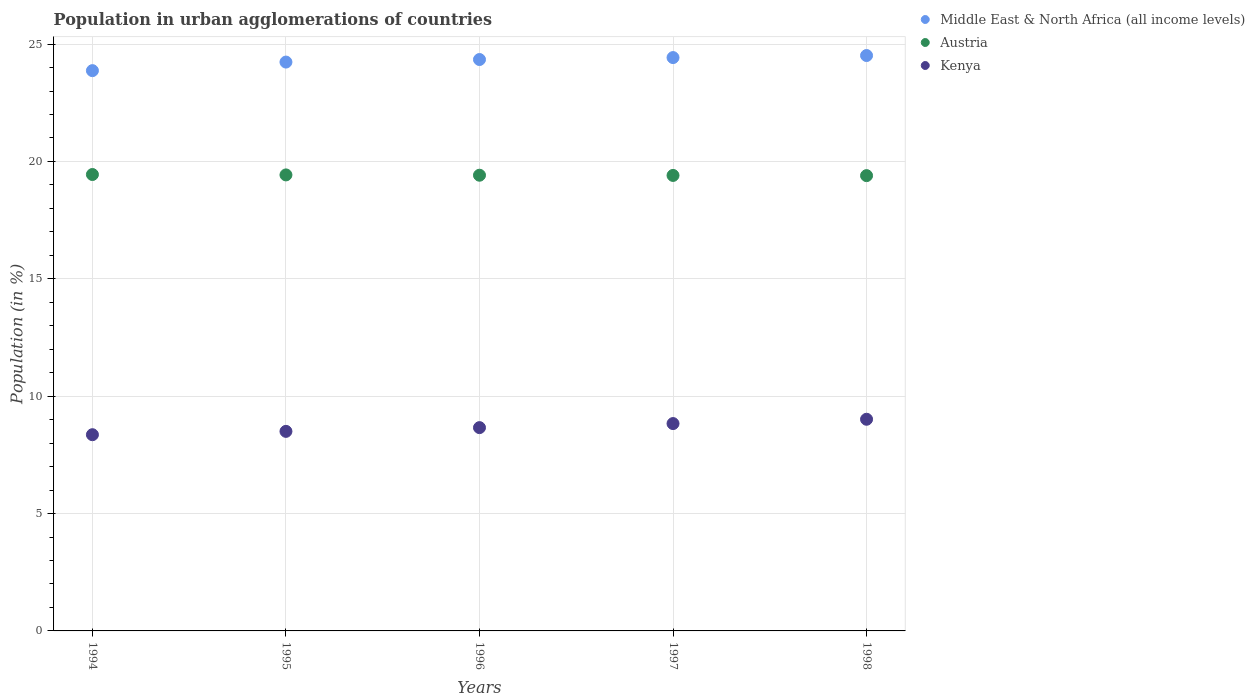Is the number of dotlines equal to the number of legend labels?
Offer a very short reply. Yes. What is the percentage of population in urban agglomerations in Austria in 1997?
Provide a short and direct response. 19.4. Across all years, what is the maximum percentage of population in urban agglomerations in Kenya?
Provide a succinct answer. 9.02. Across all years, what is the minimum percentage of population in urban agglomerations in Austria?
Your answer should be very brief. 19.4. What is the total percentage of population in urban agglomerations in Kenya in the graph?
Give a very brief answer. 43.37. What is the difference between the percentage of population in urban agglomerations in Austria in 1995 and that in 1996?
Provide a short and direct response. 0.01. What is the difference between the percentage of population in urban agglomerations in Kenya in 1997 and the percentage of population in urban agglomerations in Austria in 1996?
Offer a terse response. -10.58. What is the average percentage of population in urban agglomerations in Middle East & North Africa (all income levels) per year?
Your response must be concise. 24.28. In the year 1994, what is the difference between the percentage of population in urban agglomerations in Austria and percentage of population in urban agglomerations in Kenya?
Make the answer very short. 11.08. What is the ratio of the percentage of population in urban agglomerations in Middle East & North Africa (all income levels) in 1995 to that in 1997?
Your answer should be compact. 0.99. Is the percentage of population in urban agglomerations in Middle East & North Africa (all income levels) in 1994 less than that in 1995?
Offer a very short reply. Yes. What is the difference between the highest and the second highest percentage of population in urban agglomerations in Kenya?
Offer a terse response. 0.18. What is the difference between the highest and the lowest percentage of population in urban agglomerations in Austria?
Make the answer very short. 0.05. Is the sum of the percentage of population in urban agglomerations in Kenya in 1997 and 1998 greater than the maximum percentage of population in urban agglomerations in Middle East & North Africa (all income levels) across all years?
Give a very brief answer. No. Is it the case that in every year, the sum of the percentage of population in urban agglomerations in Middle East & North Africa (all income levels) and percentage of population in urban agglomerations in Austria  is greater than the percentage of population in urban agglomerations in Kenya?
Provide a short and direct response. Yes. How many dotlines are there?
Make the answer very short. 3. What is the difference between two consecutive major ticks on the Y-axis?
Make the answer very short. 5. Are the values on the major ticks of Y-axis written in scientific E-notation?
Ensure brevity in your answer.  No. Where does the legend appear in the graph?
Ensure brevity in your answer.  Top right. How many legend labels are there?
Give a very brief answer. 3. How are the legend labels stacked?
Provide a succinct answer. Vertical. What is the title of the graph?
Make the answer very short. Population in urban agglomerations of countries. What is the label or title of the X-axis?
Your answer should be very brief. Years. What is the Population (in %) in Middle East & North Africa (all income levels) in 1994?
Your answer should be very brief. 23.87. What is the Population (in %) of Austria in 1994?
Make the answer very short. 19.44. What is the Population (in %) in Kenya in 1994?
Keep it short and to the point. 8.36. What is the Population (in %) in Middle East & North Africa (all income levels) in 1995?
Give a very brief answer. 24.23. What is the Population (in %) of Austria in 1995?
Provide a short and direct response. 19.43. What is the Population (in %) in Kenya in 1995?
Provide a succinct answer. 8.5. What is the Population (in %) of Middle East & North Africa (all income levels) in 1996?
Offer a very short reply. 24.34. What is the Population (in %) in Austria in 1996?
Offer a terse response. 19.41. What is the Population (in %) in Kenya in 1996?
Provide a succinct answer. 8.66. What is the Population (in %) in Middle East & North Africa (all income levels) in 1997?
Provide a succinct answer. 24.42. What is the Population (in %) in Austria in 1997?
Your response must be concise. 19.4. What is the Population (in %) of Kenya in 1997?
Make the answer very short. 8.83. What is the Population (in %) in Middle East & North Africa (all income levels) in 1998?
Make the answer very short. 24.51. What is the Population (in %) in Austria in 1998?
Give a very brief answer. 19.4. What is the Population (in %) in Kenya in 1998?
Ensure brevity in your answer.  9.02. Across all years, what is the maximum Population (in %) in Middle East & North Africa (all income levels)?
Provide a short and direct response. 24.51. Across all years, what is the maximum Population (in %) in Austria?
Keep it short and to the point. 19.44. Across all years, what is the maximum Population (in %) in Kenya?
Ensure brevity in your answer.  9.02. Across all years, what is the minimum Population (in %) in Middle East & North Africa (all income levels)?
Offer a terse response. 23.87. Across all years, what is the minimum Population (in %) in Austria?
Your answer should be compact. 19.4. Across all years, what is the minimum Population (in %) in Kenya?
Provide a short and direct response. 8.36. What is the total Population (in %) in Middle East & North Africa (all income levels) in the graph?
Give a very brief answer. 121.38. What is the total Population (in %) of Austria in the graph?
Your answer should be very brief. 97.08. What is the total Population (in %) in Kenya in the graph?
Your response must be concise. 43.37. What is the difference between the Population (in %) in Middle East & North Africa (all income levels) in 1994 and that in 1995?
Keep it short and to the point. -0.36. What is the difference between the Population (in %) in Austria in 1994 and that in 1995?
Ensure brevity in your answer.  0.02. What is the difference between the Population (in %) of Kenya in 1994 and that in 1995?
Provide a succinct answer. -0.14. What is the difference between the Population (in %) of Middle East & North Africa (all income levels) in 1994 and that in 1996?
Provide a succinct answer. -0.47. What is the difference between the Population (in %) in Austria in 1994 and that in 1996?
Offer a very short reply. 0.03. What is the difference between the Population (in %) in Kenya in 1994 and that in 1996?
Make the answer very short. -0.3. What is the difference between the Population (in %) of Middle East & North Africa (all income levels) in 1994 and that in 1997?
Give a very brief answer. -0.56. What is the difference between the Population (in %) of Austria in 1994 and that in 1997?
Provide a succinct answer. 0.04. What is the difference between the Population (in %) in Kenya in 1994 and that in 1997?
Give a very brief answer. -0.47. What is the difference between the Population (in %) in Middle East & North Africa (all income levels) in 1994 and that in 1998?
Offer a very short reply. -0.64. What is the difference between the Population (in %) in Austria in 1994 and that in 1998?
Offer a very short reply. 0.05. What is the difference between the Population (in %) of Kenya in 1994 and that in 1998?
Your answer should be compact. -0.66. What is the difference between the Population (in %) of Middle East & North Africa (all income levels) in 1995 and that in 1996?
Offer a very short reply. -0.11. What is the difference between the Population (in %) of Austria in 1995 and that in 1996?
Offer a terse response. 0.01. What is the difference between the Population (in %) in Kenya in 1995 and that in 1996?
Provide a short and direct response. -0.16. What is the difference between the Population (in %) in Middle East & North Africa (all income levels) in 1995 and that in 1997?
Make the answer very short. -0.19. What is the difference between the Population (in %) in Austria in 1995 and that in 1997?
Offer a terse response. 0.02. What is the difference between the Population (in %) in Kenya in 1995 and that in 1997?
Offer a terse response. -0.33. What is the difference between the Population (in %) in Middle East & North Africa (all income levels) in 1995 and that in 1998?
Provide a short and direct response. -0.28. What is the difference between the Population (in %) of Austria in 1995 and that in 1998?
Give a very brief answer. 0.03. What is the difference between the Population (in %) of Kenya in 1995 and that in 1998?
Make the answer very short. -0.52. What is the difference between the Population (in %) of Middle East & North Africa (all income levels) in 1996 and that in 1997?
Keep it short and to the point. -0.08. What is the difference between the Population (in %) in Austria in 1996 and that in 1997?
Ensure brevity in your answer.  0.01. What is the difference between the Population (in %) in Kenya in 1996 and that in 1997?
Give a very brief answer. -0.17. What is the difference between the Population (in %) of Middle East & North Africa (all income levels) in 1996 and that in 1998?
Give a very brief answer. -0.17. What is the difference between the Population (in %) in Austria in 1996 and that in 1998?
Your answer should be very brief. 0.02. What is the difference between the Population (in %) in Kenya in 1996 and that in 1998?
Offer a terse response. -0.36. What is the difference between the Population (in %) of Middle East & North Africa (all income levels) in 1997 and that in 1998?
Give a very brief answer. -0.09. What is the difference between the Population (in %) in Austria in 1997 and that in 1998?
Give a very brief answer. 0.01. What is the difference between the Population (in %) of Kenya in 1997 and that in 1998?
Offer a terse response. -0.18. What is the difference between the Population (in %) of Middle East & North Africa (all income levels) in 1994 and the Population (in %) of Austria in 1995?
Offer a very short reply. 4.44. What is the difference between the Population (in %) in Middle East & North Africa (all income levels) in 1994 and the Population (in %) in Kenya in 1995?
Your answer should be very brief. 15.37. What is the difference between the Population (in %) of Austria in 1994 and the Population (in %) of Kenya in 1995?
Provide a short and direct response. 10.94. What is the difference between the Population (in %) of Middle East & North Africa (all income levels) in 1994 and the Population (in %) of Austria in 1996?
Give a very brief answer. 4.46. What is the difference between the Population (in %) of Middle East & North Africa (all income levels) in 1994 and the Population (in %) of Kenya in 1996?
Offer a terse response. 15.21. What is the difference between the Population (in %) in Austria in 1994 and the Population (in %) in Kenya in 1996?
Make the answer very short. 10.78. What is the difference between the Population (in %) of Middle East & North Africa (all income levels) in 1994 and the Population (in %) of Austria in 1997?
Your answer should be compact. 4.46. What is the difference between the Population (in %) of Middle East & North Africa (all income levels) in 1994 and the Population (in %) of Kenya in 1997?
Your response must be concise. 15.04. What is the difference between the Population (in %) in Austria in 1994 and the Population (in %) in Kenya in 1997?
Keep it short and to the point. 10.61. What is the difference between the Population (in %) in Middle East & North Africa (all income levels) in 1994 and the Population (in %) in Austria in 1998?
Give a very brief answer. 4.47. What is the difference between the Population (in %) in Middle East & North Africa (all income levels) in 1994 and the Population (in %) in Kenya in 1998?
Make the answer very short. 14.85. What is the difference between the Population (in %) in Austria in 1994 and the Population (in %) in Kenya in 1998?
Provide a succinct answer. 10.43. What is the difference between the Population (in %) in Middle East & North Africa (all income levels) in 1995 and the Population (in %) in Austria in 1996?
Your response must be concise. 4.82. What is the difference between the Population (in %) in Middle East & North Africa (all income levels) in 1995 and the Population (in %) in Kenya in 1996?
Your answer should be compact. 15.57. What is the difference between the Population (in %) in Austria in 1995 and the Population (in %) in Kenya in 1996?
Make the answer very short. 10.77. What is the difference between the Population (in %) in Middle East & North Africa (all income levels) in 1995 and the Population (in %) in Austria in 1997?
Provide a short and direct response. 4.83. What is the difference between the Population (in %) in Middle East & North Africa (all income levels) in 1995 and the Population (in %) in Kenya in 1997?
Keep it short and to the point. 15.4. What is the difference between the Population (in %) of Austria in 1995 and the Population (in %) of Kenya in 1997?
Keep it short and to the point. 10.59. What is the difference between the Population (in %) of Middle East & North Africa (all income levels) in 1995 and the Population (in %) of Austria in 1998?
Ensure brevity in your answer.  4.84. What is the difference between the Population (in %) of Middle East & North Africa (all income levels) in 1995 and the Population (in %) of Kenya in 1998?
Give a very brief answer. 15.22. What is the difference between the Population (in %) in Austria in 1995 and the Population (in %) in Kenya in 1998?
Make the answer very short. 10.41. What is the difference between the Population (in %) of Middle East & North Africa (all income levels) in 1996 and the Population (in %) of Austria in 1997?
Give a very brief answer. 4.94. What is the difference between the Population (in %) of Middle East & North Africa (all income levels) in 1996 and the Population (in %) of Kenya in 1997?
Offer a terse response. 15.51. What is the difference between the Population (in %) in Austria in 1996 and the Population (in %) in Kenya in 1997?
Offer a very short reply. 10.58. What is the difference between the Population (in %) in Middle East & North Africa (all income levels) in 1996 and the Population (in %) in Austria in 1998?
Your answer should be very brief. 4.95. What is the difference between the Population (in %) of Middle East & North Africa (all income levels) in 1996 and the Population (in %) of Kenya in 1998?
Make the answer very short. 15.33. What is the difference between the Population (in %) of Austria in 1996 and the Population (in %) of Kenya in 1998?
Provide a short and direct response. 10.4. What is the difference between the Population (in %) of Middle East & North Africa (all income levels) in 1997 and the Population (in %) of Austria in 1998?
Keep it short and to the point. 5.03. What is the difference between the Population (in %) in Middle East & North Africa (all income levels) in 1997 and the Population (in %) in Kenya in 1998?
Offer a terse response. 15.41. What is the difference between the Population (in %) of Austria in 1997 and the Population (in %) of Kenya in 1998?
Your response must be concise. 10.39. What is the average Population (in %) of Middle East & North Africa (all income levels) per year?
Provide a short and direct response. 24.28. What is the average Population (in %) of Austria per year?
Your response must be concise. 19.42. What is the average Population (in %) of Kenya per year?
Keep it short and to the point. 8.67. In the year 1994, what is the difference between the Population (in %) of Middle East & North Africa (all income levels) and Population (in %) of Austria?
Offer a terse response. 4.42. In the year 1994, what is the difference between the Population (in %) of Middle East & North Africa (all income levels) and Population (in %) of Kenya?
Your response must be concise. 15.51. In the year 1994, what is the difference between the Population (in %) of Austria and Population (in %) of Kenya?
Ensure brevity in your answer.  11.08. In the year 1995, what is the difference between the Population (in %) in Middle East & North Africa (all income levels) and Population (in %) in Austria?
Make the answer very short. 4.81. In the year 1995, what is the difference between the Population (in %) in Middle East & North Africa (all income levels) and Population (in %) in Kenya?
Ensure brevity in your answer.  15.73. In the year 1995, what is the difference between the Population (in %) in Austria and Population (in %) in Kenya?
Provide a short and direct response. 10.93. In the year 1996, what is the difference between the Population (in %) in Middle East & North Africa (all income levels) and Population (in %) in Austria?
Give a very brief answer. 4.93. In the year 1996, what is the difference between the Population (in %) in Middle East & North Africa (all income levels) and Population (in %) in Kenya?
Your response must be concise. 15.68. In the year 1996, what is the difference between the Population (in %) of Austria and Population (in %) of Kenya?
Provide a succinct answer. 10.75. In the year 1997, what is the difference between the Population (in %) in Middle East & North Africa (all income levels) and Population (in %) in Austria?
Ensure brevity in your answer.  5.02. In the year 1997, what is the difference between the Population (in %) of Middle East & North Africa (all income levels) and Population (in %) of Kenya?
Offer a terse response. 15.59. In the year 1997, what is the difference between the Population (in %) in Austria and Population (in %) in Kenya?
Keep it short and to the point. 10.57. In the year 1998, what is the difference between the Population (in %) of Middle East & North Africa (all income levels) and Population (in %) of Austria?
Your response must be concise. 5.12. In the year 1998, what is the difference between the Population (in %) of Middle East & North Africa (all income levels) and Population (in %) of Kenya?
Offer a very short reply. 15.5. In the year 1998, what is the difference between the Population (in %) in Austria and Population (in %) in Kenya?
Provide a short and direct response. 10.38. What is the ratio of the Population (in %) in Middle East & North Africa (all income levels) in 1994 to that in 1995?
Provide a succinct answer. 0.98. What is the ratio of the Population (in %) in Austria in 1994 to that in 1995?
Keep it short and to the point. 1. What is the ratio of the Population (in %) of Kenya in 1994 to that in 1995?
Provide a succinct answer. 0.98. What is the ratio of the Population (in %) in Middle East & North Africa (all income levels) in 1994 to that in 1996?
Your answer should be very brief. 0.98. What is the ratio of the Population (in %) of Kenya in 1994 to that in 1996?
Keep it short and to the point. 0.97. What is the ratio of the Population (in %) in Middle East & North Africa (all income levels) in 1994 to that in 1997?
Your answer should be compact. 0.98. What is the ratio of the Population (in %) in Austria in 1994 to that in 1997?
Offer a very short reply. 1. What is the ratio of the Population (in %) of Kenya in 1994 to that in 1997?
Ensure brevity in your answer.  0.95. What is the ratio of the Population (in %) of Middle East & North Africa (all income levels) in 1994 to that in 1998?
Your answer should be compact. 0.97. What is the ratio of the Population (in %) in Kenya in 1994 to that in 1998?
Make the answer very short. 0.93. What is the ratio of the Population (in %) in Kenya in 1995 to that in 1996?
Offer a terse response. 0.98. What is the ratio of the Population (in %) in Austria in 1995 to that in 1997?
Make the answer very short. 1. What is the ratio of the Population (in %) in Kenya in 1995 to that in 1997?
Provide a succinct answer. 0.96. What is the ratio of the Population (in %) of Austria in 1995 to that in 1998?
Offer a very short reply. 1. What is the ratio of the Population (in %) in Kenya in 1995 to that in 1998?
Provide a succinct answer. 0.94. What is the ratio of the Population (in %) of Middle East & North Africa (all income levels) in 1996 to that in 1997?
Ensure brevity in your answer.  1. What is the ratio of the Population (in %) in Austria in 1996 to that in 1997?
Offer a terse response. 1. What is the ratio of the Population (in %) in Kenya in 1996 to that in 1997?
Give a very brief answer. 0.98. What is the ratio of the Population (in %) in Middle East & North Africa (all income levels) in 1996 to that in 1998?
Offer a very short reply. 0.99. What is the ratio of the Population (in %) in Kenya in 1996 to that in 1998?
Your answer should be compact. 0.96. What is the ratio of the Population (in %) of Kenya in 1997 to that in 1998?
Your response must be concise. 0.98. What is the difference between the highest and the second highest Population (in %) of Middle East & North Africa (all income levels)?
Give a very brief answer. 0.09. What is the difference between the highest and the second highest Population (in %) of Austria?
Your answer should be very brief. 0.02. What is the difference between the highest and the second highest Population (in %) of Kenya?
Ensure brevity in your answer.  0.18. What is the difference between the highest and the lowest Population (in %) in Middle East & North Africa (all income levels)?
Your response must be concise. 0.64. What is the difference between the highest and the lowest Population (in %) of Austria?
Give a very brief answer. 0.05. What is the difference between the highest and the lowest Population (in %) in Kenya?
Your answer should be very brief. 0.66. 